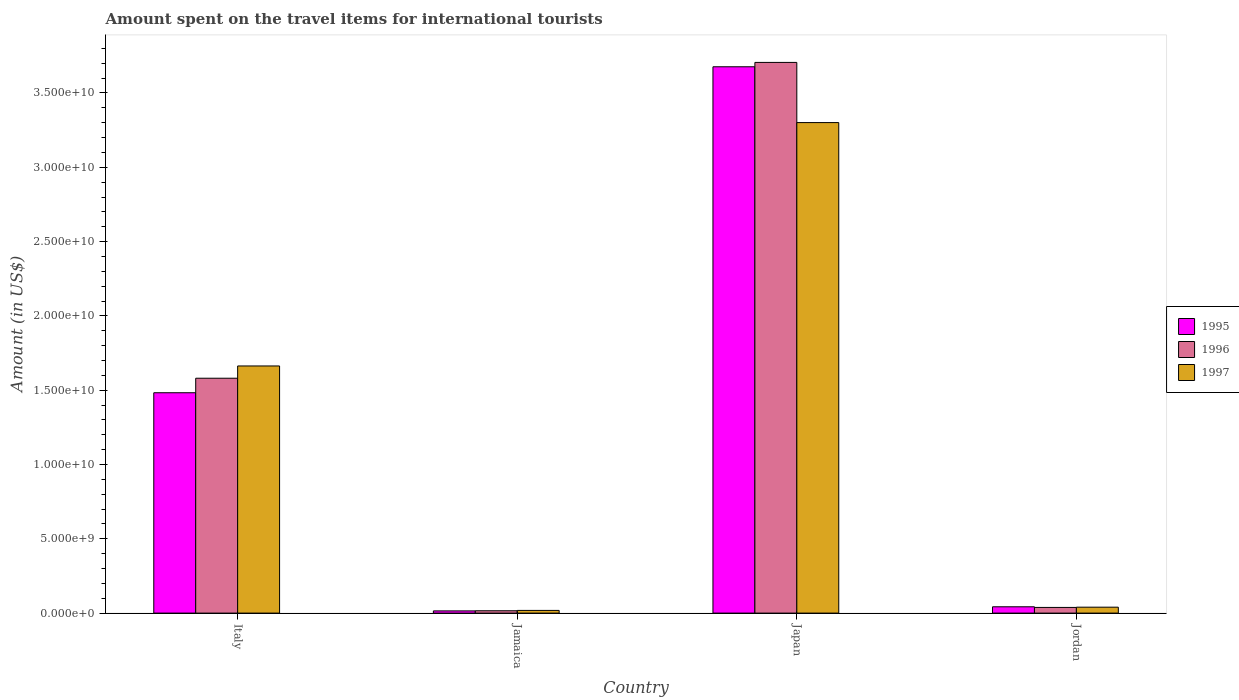How many different coloured bars are there?
Provide a succinct answer. 3. How many groups of bars are there?
Offer a terse response. 4. How many bars are there on the 3rd tick from the left?
Offer a very short reply. 3. What is the amount spent on the travel items for international tourists in 1995 in Jordan?
Offer a very short reply. 4.25e+08. Across all countries, what is the maximum amount spent on the travel items for international tourists in 1995?
Provide a short and direct response. 3.68e+1. Across all countries, what is the minimum amount spent on the travel items for international tourists in 1997?
Ensure brevity in your answer.  1.81e+08. In which country was the amount spent on the travel items for international tourists in 1996 maximum?
Keep it short and to the point. Japan. In which country was the amount spent on the travel items for international tourists in 1997 minimum?
Your response must be concise. Jamaica. What is the total amount spent on the travel items for international tourists in 1996 in the graph?
Make the answer very short. 5.34e+1. What is the difference between the amount spent on the travel items for international tourists in 1996 in Italy and that in Jamaica?
Offer a terse response. 1.56e+1. What is the difference between the amount spent on the travel items for international tourists in 1995 in Jordan and the amount spent on the travel items for international tourists in 1997 in Jamaica?
Give a very brief answer. 2.44e+08. What is the average amount spent on the travel items for international tourists in 1995 per country?
Provide a short and direct response. 1.30e+1. What is the difference between the amount spent on the travel items for international tourists of/in 1997 and amount spent on the travel items for international tourists of/in 1996 in Japan?
Offer a terse response. -4.05e+09. In how many countries, is the amount spent on the travel items for international tourists in 1996 greater than 6000000000 US$?
Keep it short and to the point. 2. What is the ratio of the amount spent on the travel items for international tourists in 1996 in Italy to that in Jamaica?
Your response must be concise. 100.67. Is the amount spent on the travel items for international tourists in 1996 in Italy less than that in Jamaica?
Your response must be concise. No. Is the difference between the amount spent on the travel items for international tourists in 1997 in Italy and Jamaica greater than the difference between the amount spent on the travel items for international tourists in 1996 in Italy and Jamaica?
Make the answer very short. Yes. What is the difference between the highest and the second highest amount spent on the travel items for international tourists in 1997?
Your answer should be very brief. 3.26e+1. What is the difference between the highest and the lowest amount spent on the travel items for international tourists in 1995?
Make the answer very short. 3.66e+1. Is it the case that in every country, the sum of the amount spent on the travel items for international tourists in 1996 and amount spent on the travel items for international tourists in 1995 is greater than the amount spent on the travel items for international tourists in 1997?
Your answer should be compact. Yes. How many bars are there?
Make the answer very short. 12. Are all the bars in the graph horizontal?
Provide a succinct answer. No. How many countries are there in the graph?
Offer a very short reply. 4. What is the difference between two consecutive major ticks on the Y-axis?
Give a very brief answer. 5.00e+09. Are the values on the major ticks of Y-axis written in scientific E-notation?
Your answer should be compact. Yes. Does the graph contain grids?
Offer a terse response. No. Where does the legend appear in the graph?
Your answer should be compact. Center right. What is the title of the graph?
Your answer should be very brief. Amount spent on the travel items for international tourists. What is the label or title of the X-axis?
Offer a very short reply. Country. What is the Amount (in US$) of 1995 in Italy?
Make the answer very short. 1.48e+1. What is the Amount (in US$) in 1996 in Italy?
Your answer should be compact. 1.58e+1. What is the Amount (in US$) in 1997 in Italy?
Your answer should be compact. 1.66e+1. What is the Amount (in US$) of 1995 in Jamaica?
Offer a terse response. 1.48e+08. What is the Amount (in US$) of 1996 in Jamaica?
Make the answer very short. 1.57e+08. What is the Amount (in US$) of 1997 in Jamaica?
Provide a short and direct response. 1.81e+08. What is the Amount (in US$) in 1995 in Japan?
Offer a terse response. 3.68e+1. What is the Amount (in US$) in 1996 in Japan?
Make the answer very short. 3.71e+1. What is the Amount (in US$) of 1997 in Japan?
Provide a succinct answer. 3.30e+1. What is the Amount (in US$) in 1995 in Jordan?
Provide a succinct answer. 4.25e+08. What is the Amount (in US$) in 1996 in Jordan?
Ensure brevity in your answer.  3.81e+08. What is the Amount (in US$) of 1997 in Jordan?
Your answer should be compact. 3.98e+08. Across all countries, what is the maximum Amount (in US$) in 1995?
Provide a short and direct response. 3.68e+1. Across all countries, what is the maximum Amount (in US$) of 1996?
Give a very brief answer. 3.71e+1. Across all countries, what is the maximum Amount (in US$) in 1997?
Your answer should be compact. 3.30e+1. Across all countries, what is the minimum Amount (in US$) of 1995?
Your answer should be compact. 1.48e+08. Across all countries, what is the minimum Amount (in US$) in 1996?
Your response must be concise. 1.57e+08. Across all countries, what is the minimum Amount (in US$) of 1997?
Provide a succinct answer. 1.81e+08. What is the total Amount (in US$) of 1995 in the graph?
Make the answer very short. 5.22e+1. What is the total Amount (in US$) in 1996 in the graph?
Ensure brevity in your answer.  5.34e+1. What is the total Amount (in US$) in 1997 in the graph?
Give a very brief answer. 5.02e+1. What is the difference between the Amount (in US$) of 1995 in Italy and that in Jamaica?
Keep it short and to the point. 1.47e+1. What is the difference between the Amount (in US$) in 1996 in Italy and that in Jamaica?
Provide a short and direct response. 1.56e+1. What is the difference between the Amount (in US$) in 1997 in Italy and that in Jamaica?
Your response must be concise. 1.64e+1. What is the difference between the Amount (in US$) in 1995 in Italy and that in Japan?
Provide a succinct answer. -2.19e+1. What is the difference between the Amount (in US$) of 1996 in Italy and that in Japan?
Offer a terse response. -2.13e+1. What is the difference between the Amount (in US$) of 1997 in Italy and that in Japan?
Your answer should be compact. -1.64e+1. What is the difference between the Amount (in US$) in 1995 in Italy and that in Jordan?
Your response must be concise. 1.44e+1. What is the difference between the Amount (in US$) in 1996 in Italy and that in Jordan?
Offer a very short reply. 1.54e+1. What is the difference between the Amount (in US$) of 1997 in Italy and that in Jordan?
Offer a very short reply. 1.62e+1. What is the difference between the Amount (in US$) in 1995 in Jamaica and that in Japan?
Keep it short and to the point. -3.66e+1. What is the difference between the Amount (in US$) in 1996 in Jamaica and that in Japan?
Give a very brief answer. -3.69e+1. What is the difference between the Amount (in US$) of 1997 in Jamaica and that in Japan?
Make the answer very short. -3.28e+1. What is the difference between the Amount (in US$) in 1995 in Jamaica and that in Jordan?
Offer a terse response. -2.77e+08. What is the difference between the Amount (in US$) in 1996 in Jamaica and that in Jordan?
Make the answer very short. -2.24e+08. What is the difference between the Amount (in US$) of 1997 in Jamaica and that in Jordan?
Give a very brief answer. -2.17e+08. What is the difference between the Amount (in US$) of 1995 in Japan and that in Jordan?
Offer a terse response. 3.63e+1. What is the difference between the Amount (in US$) in 1996 in Japan and that in Jordan?
Offer a terse response. 3.67e+1. What is the difference between the Amount (in US$) in 1997 in Japan and that in Jordan?
Keep it short and to the point. 3.26e+1. What is the difference between the Amount (in US$) in 1995 in Italy and the Amount (in US$) in 1996 in Jamaica?
Ensure brevity in your answer.  1.47e+1. What is the difference between the Amount (in US$) of 1995 in Italy and the Amount (in US$) of 1997 in Jamaica?
Offer a very short reply. 1.46e+1. What is the difference between the Amount (in US$) in 1996 in Italy and the Amount (in US$) in 1997 in Jamaica?
Your answer should be very brief. 1.56e+1. What is the difference between the Amount (in US$) of 1995 in Italy and the Amount (in US$) of 1996 in Japan?
Ensure brevity in your answer.  -2.22e+1. What is the difference between the Amount (in US$) in 1995 in Italy and the Amount (in US$) in 1997 in Japan?
Offer a very short reply. -1.82e+1. What is the difference between the Amount (in US$) of 1996 in Italy and the Amount (in US$) of 1997 in Japan?
Provide a short and direct response. -1.72e+1. What is the difference between the Amount (in US$) in 1995 in Italy and the Amount (in US$) in 1996 in Jordan?
Offer a terse response. 1.44e+1. What is the difference between the Amount (in US$) in 1995 in Italy and the Amount (in US$) in 1997 in Jordan?
Your response must be concise. 1.44e+1. What is the difference between the Amount (in US$) of 1996 in Italy and the Amount (in US$) of 1997 in Jordan?
Provide a succinct answer. 1.54e+1. What is the difference between the Amount (in US$) in 1995 in Jamaica and the Amount (in US$) in 1996 in Japan?
Ensure brevity in your answer.  -3.69e+1. What is the difference between the Amount (in US$) in 1995 in Jamaica and the Amount (in US$) in 1997 in Japan?
Provide a succinct answer. -3.29e+1. What is the difference between the Amount (in US$) of 1996 in Jamaica and the Amount (in US$) of 1997 in Japan?
Ensure brevity in your answer.  -3.29e+1. What is the difference between the Amount (in US$) of 1995 in Jamaica and the Amount (in US$) of 1996 in Jordan?
Your response must be concise. -2.33e+08. What is the difference between the Amount (in US$) of 1995 in Jamaica and the Amount (in US$) of 1997 in Jordan?
Your answer should be compact. -2.50e+08. What is the difference between the Amount (in US$) in 1996 in Jamaica and the Amount (in US$) in 1997 in Jordan?
Provide a short and direct response. -2.41e+08. What is the difference between the Amount (in US$) in 1995 in Japan and the Amount (in US$) in 1996 in Jordan?
Your response must be concise. 3.64e+1. What is the difference between the Amount (in US$) of 1995 in Japan and the Amount (in US$) of 1997 in Jordan?
Your answer should be very brief. 3.64e+1. What is the difference between the Amount (in US$) of 1996 in Japan and the Amount (in US$) of 1997 in Jordan?
Make the answer very short. 3.67e+1. What is the average Amount (in US$) in 1995 per country?
Your answer should be compact. 1.30e+1. What is the average Amount (in US$) in 1996 per country?
Offer a very short reply. 1.34e+1. What is the average Amount (in US$) in 1997 per country?
Make the answer very short. 1.26e+1. What is the difference between the Amount (in US$) in 1995 and Amount (in US$) in 1996 in Italy?
Give a very brief answer. -9.76e+08. What is the difference between the Amount (in US$) in 1995 and Amount (in US$) in 1997 in Italy?
Keep it short and to the point. -1.80e+09. What is the difference between the Amount (in US$) of 1996 and Amount (in US$) of 1997 in Italy?
Make the answer very short. -8.26e+08. What is the difference between the Amount (in US$) in 1995 and Amount (in US$) in 1996 in Jamaica?
Your answer should be compact. -9.00e+06. What is the difference between the Amount (in US$) in 1995 and Amount (in US$) in 1997 in Jamaica?
Offer a terse response. -3.30e+07. What is the difference between the Amount (in US$) in 1996 and Amount (in US$) in 1997 in Jamaica?
Give a very brief answer. -2.40e+07. What is the difference between the Amount (in US$) in 1995 and Amount (in US$) in 1996 in Japan?
Your answer should be compact. -2.94e+08. What is the difference between the Amount (in US$) in 1995 and Amount (in US$) in 1997 in Japan?
Keep it short and to the point. 3.76e+09. What is the difference between the Amount (in US$) of 1996 and Amount (in US$) of 1997 in Japan?
Give a very brief answer. 4.05e+09. What is the difference between the Amount (in US$) of 1995 and Amount (in US$) of 1996 in Jordan?
Offer a very short reply. 4.40e+07. What is the difference between the Amount (in US$) of 1995 and Amount (in US$) of 1997 in Jordan?
Your answer should be very brief. 2.70e+07. What is the difference between the Amount (in US$) in 1996 and Amount (in US$) in 1997 in Jordan?
Provide a short and direct response. -1.70e+07. What is the ratio of the Amount (in US$) in 1995 in Italy to that in Jamaica?
Your answer should be compact. 100.2. What is the ratio of the Amount (in US$) in 1996 in Italy to that in Jamaica?
Offer a very short reply. 100.67. What is the ratio of the Amount (in US$) of 1997 in Italy to that in Jamaica?
Your answer should be very brief. 91.88. What is the ratio of the Amount (in US$) in 1995 in Italy to that in Japan?
Give a very brief answer. 0.4. What is the ratio of the Amount (in US$) in 1996 in Italy to that in Japan?
Provide a succinct answer. 0.43. What is the ratio of the Amount (in US$) of 1997 in Italy to that in Japan?
Keep it short and to the point. 0.5. What is the ratio of the Amount (in US$) in 1995 in Italy to that in Jordan?
Offer a very short reply. 34.89. What is the ratio of the Amount (in US$) in 1996 in Italy to that in Jordan?
Make the answer very short. 41.48. What is the ratio of the Amount (in US$) in 1997 in Italy to that in Jordan?
Keep it short and to the point. 41.79. What is the ratio of the Amount (in US$) in 1995 in Jamaica to that in Japan?
Keep it short and to the point. 0. What is the ratio of the Amount (in US$) of 1996 in Jamaica to that in Japan?
Ensure brevity in your answer.  0. What is the ratio of the Amount (in US$) of 1997 in Jamaica to that in Japan?
Offer a very short reply. 0.01. What is the ratio of the Amount (in US$) in 1995 in Jamaica to that in Jordan?
Offer a very short reply. 0.35. What is the ratio of the Amount (in US$) of 1996 in Jamaica to that in Jordan?
Provide a succinct answer. 0.41. What is the ratio of the Amount (in US$) of 1997 in Jamaica to that in Jordan?
Keep it short and to the point. 0.45. What is the ratio of the Amount (in US$) in 1995 in Japan to that in Jordan?
Provide a short and direct response. 86.5. What is the ratio of the Amount (in US$) in 1996 in Japan to that in Jordan?
Give a very brief answer. 97.27. What is the ratio of the Amount (in US$) of 1997 in Japan to that in Jordan?
Provide a short and direct response. 82.94. What is the difference between the highest and the second highest Amount (in US$) in 1995?
Offer a very short reply. 2.19e+1. What is the difference between the highest and the second highest Amount (in US$) in 1996?
Your answer should be compact. 2.13e+1. What is the difference between the highest and the second highest Amount (in US$) in 1997?
Your response must be concise. 1.64e+1. What is the difference between the highest and the lowest Amount (in US$) of 1995?
Your answer should be compact. 3.66e+1. What is the difference between the highest and the lowest Amount (in US$) of 1996?
Keep it short and to the point. 3.69e+1. What is the difference between the highest and the lowest Amount (in US$) of 1997?
Your answer should be compact. 3.28e+1. 